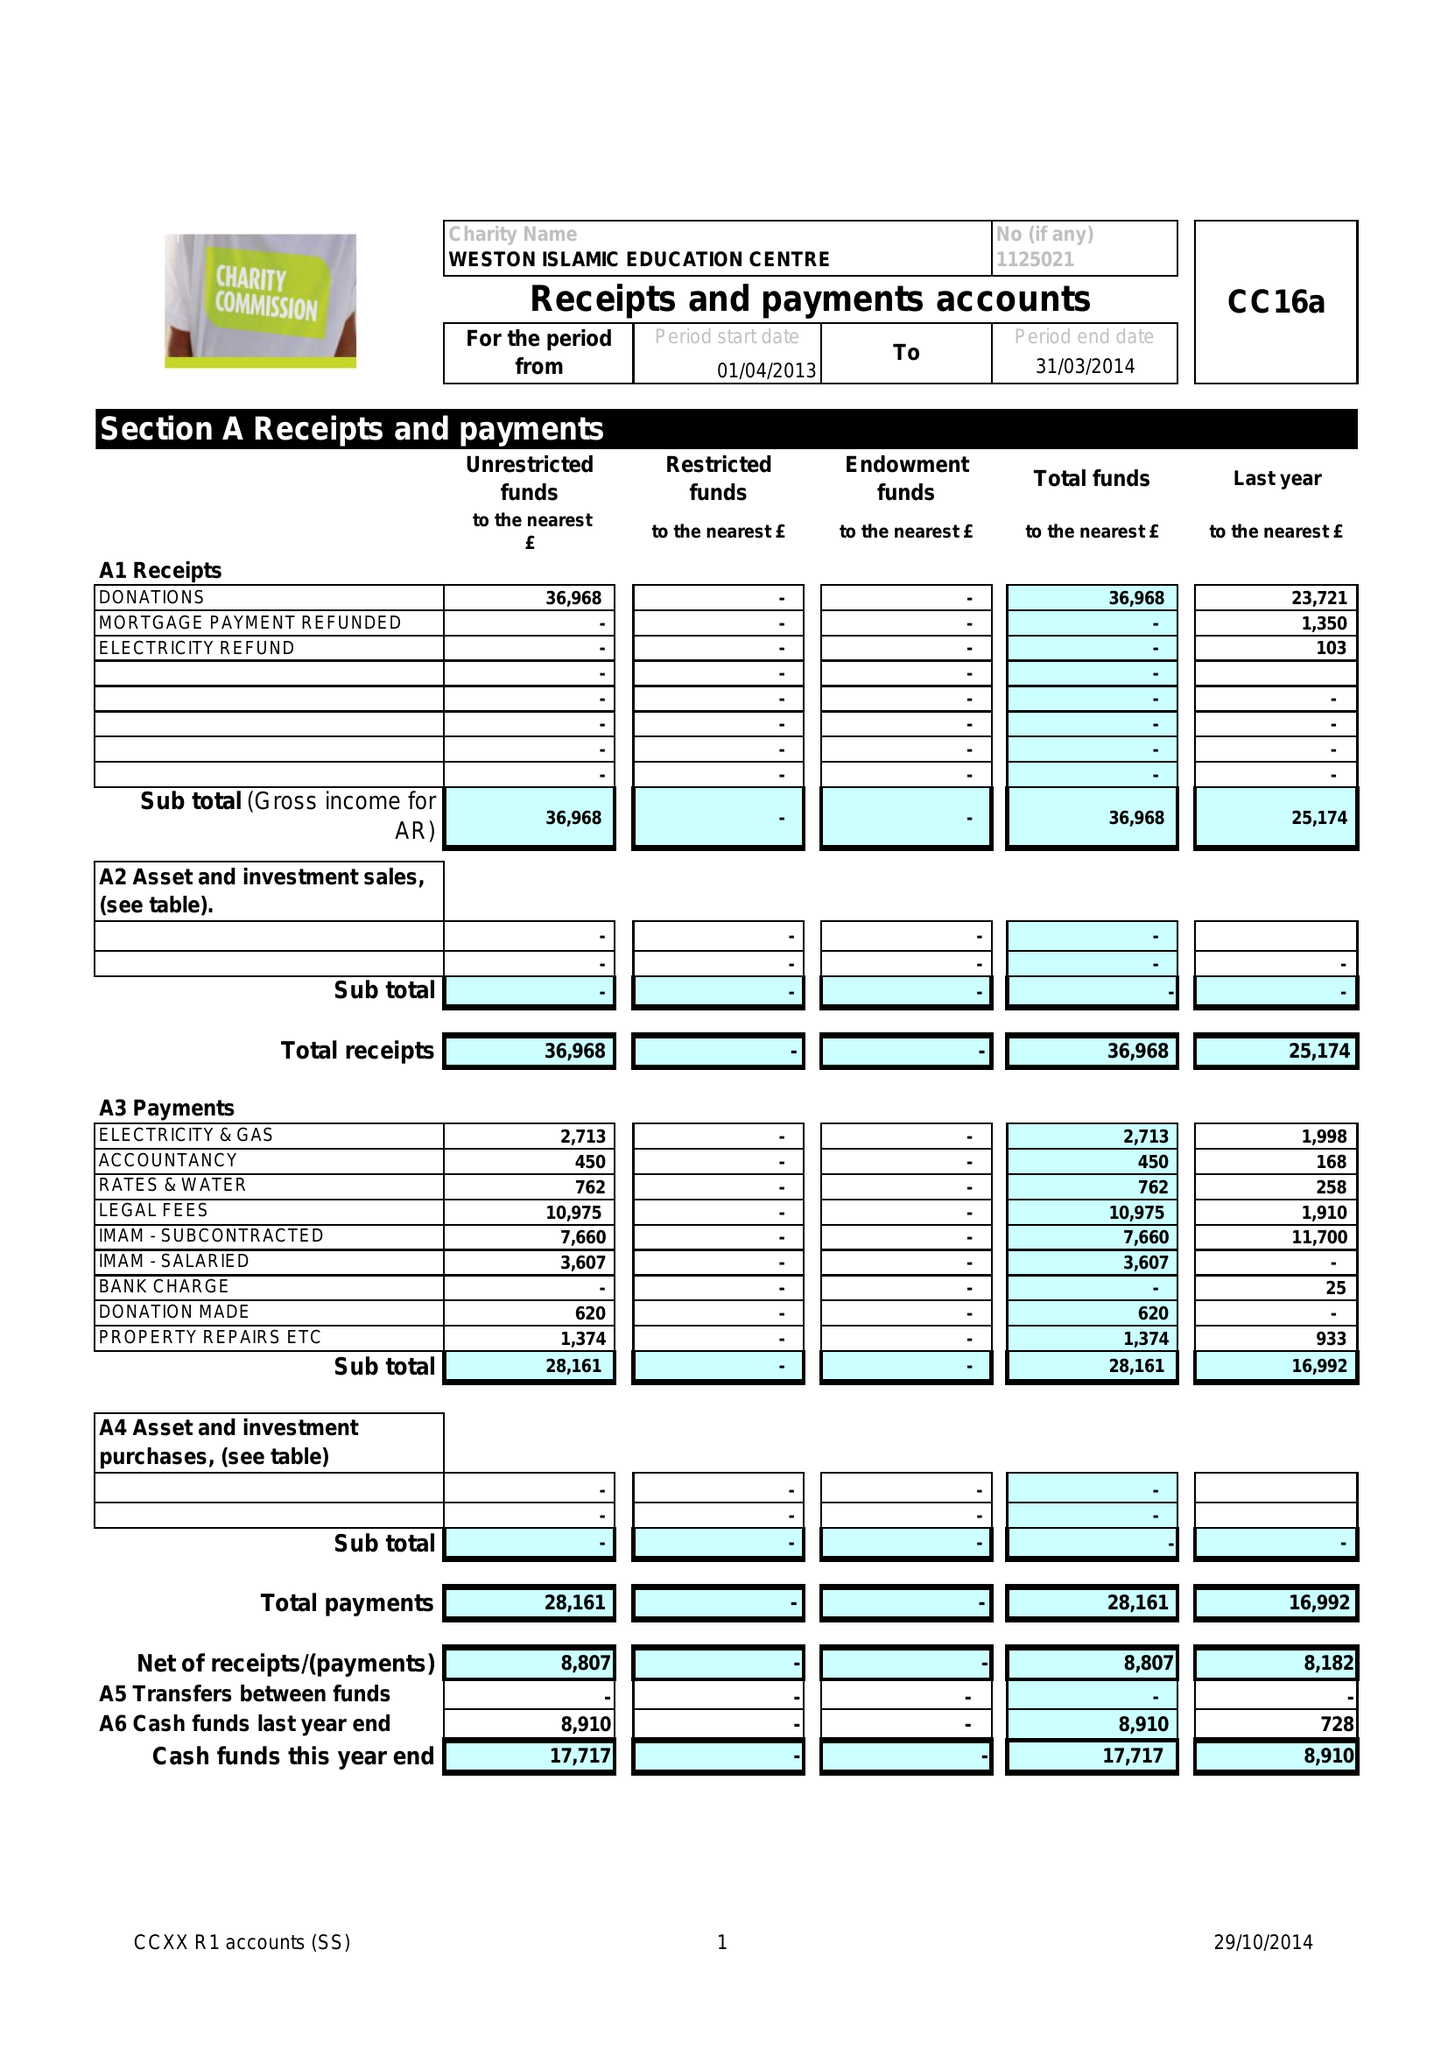What is the value for the charity_name?
Answer the question using a single word or phrase. Weston Islamic Education Centre 